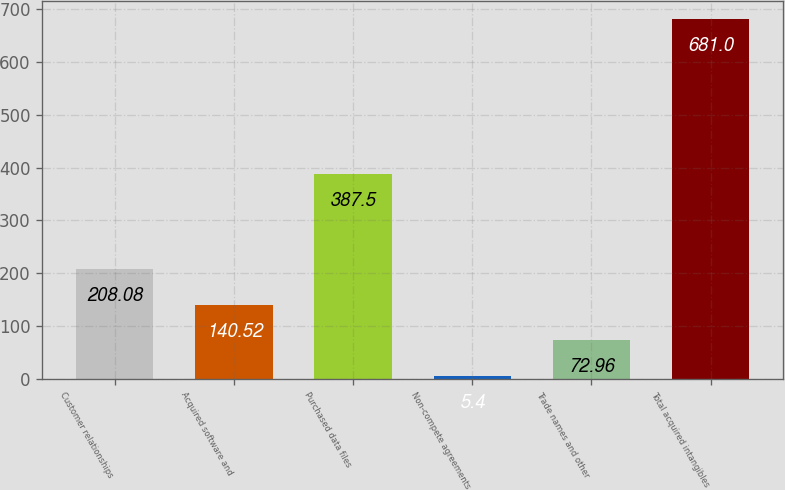<chart> <loc_0><loc_0><loc_500><loc_500><bar_chart><fcel>Customer relationships<fcel>Acquired software and<fcel>Purchased data files<fcel>Non-compete agreements<fcel>Trade names and other<fcel>Total acquired intangibles<nl><fcel>208.08<fcel>140.52<fcel>387.5<fcel>5.4<fcel>72.96<fcel>681<nl></chart> 